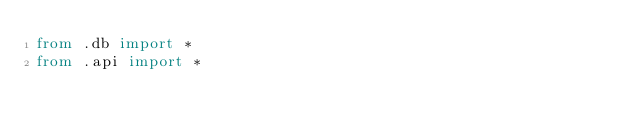Convert code to text. <code><loc_0><loc_0><loc_500><loc_500><_Python_>from .db import *
from .api import *</code> 